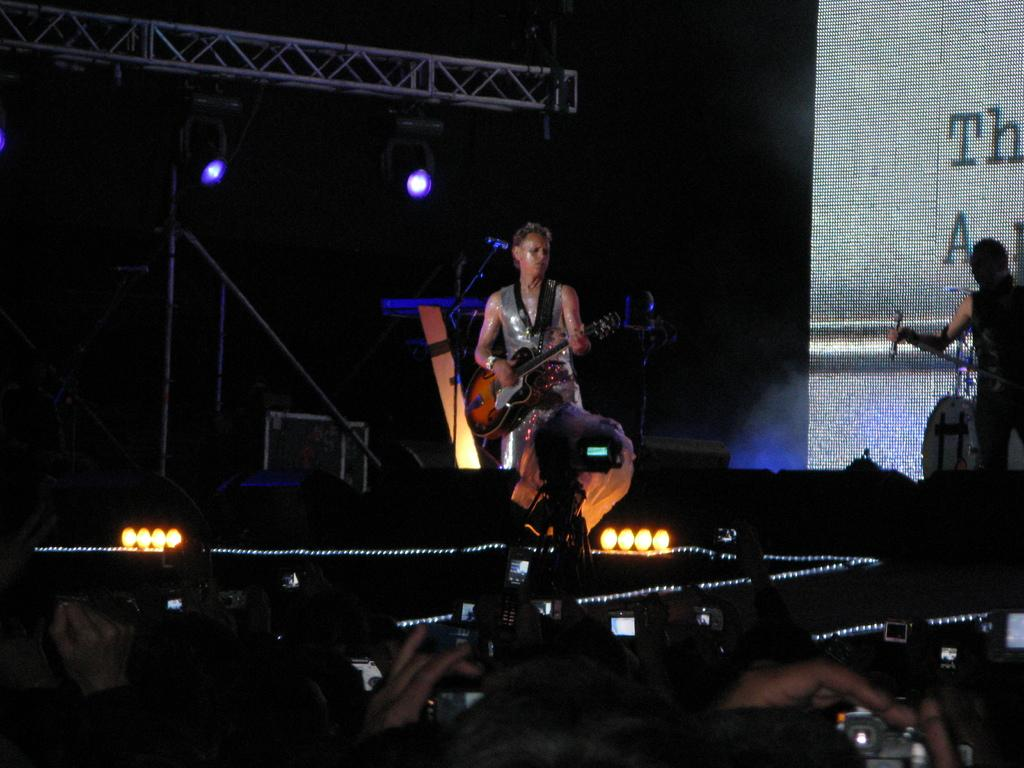Who is the main subject in the image? There is a woman in the image. What is the woman doing in the image? The woman is standing and playing a guitar. What can be seen in the background of the image? There is a camera, a screen, focus lights, and iron rods in the background of the image. What type of vegetable is the woman using as a pick for her guitar in the image? There is no vegetable present in the image, and the woman is not using any object as a pick for her guitar. 